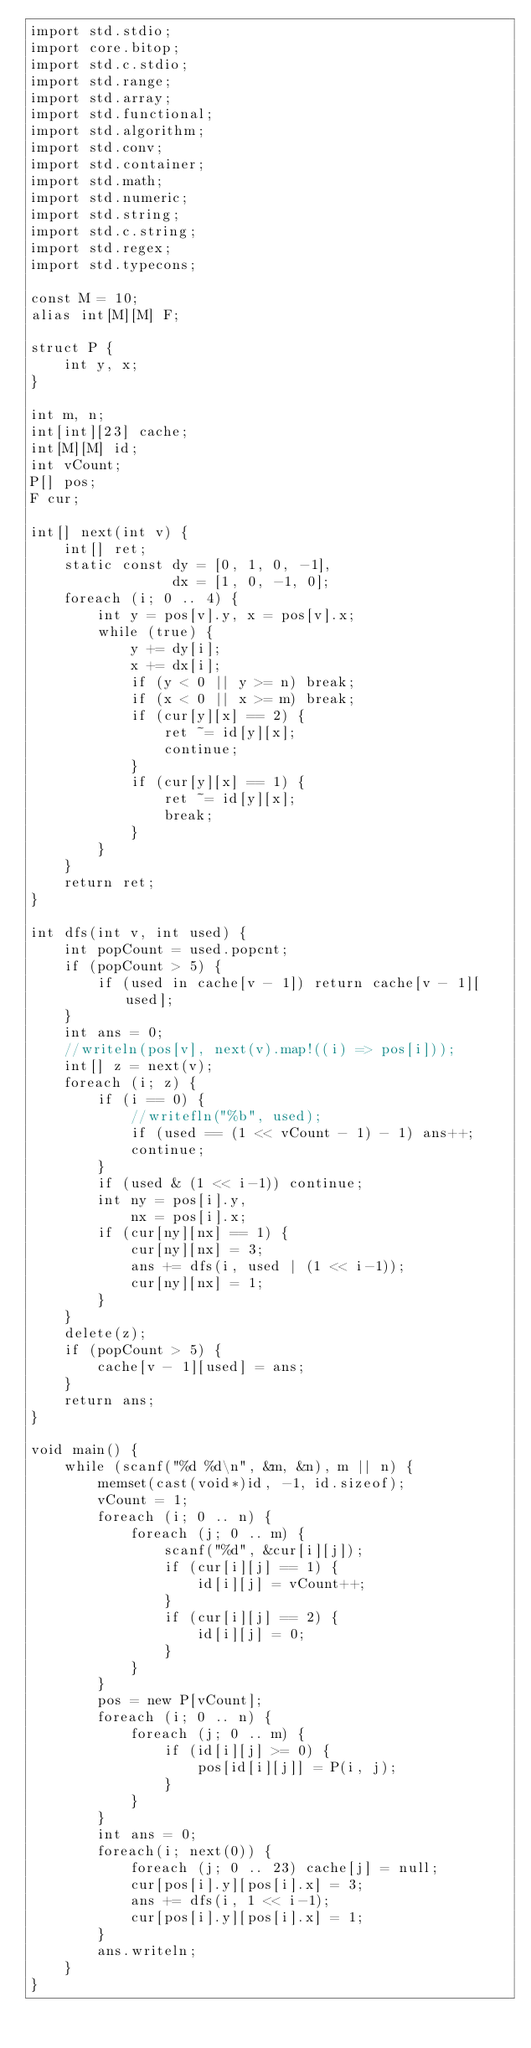Convert code to text. <code><loc_0><loc_0><loc_500><loc_500><_D_>import std.stdio;
import core.bitop;
import std.c.stdio;
import std.range;
import std.array;
import std.functional;
import std.algorithm;
import std.conv;
import std.container;
import std.math;
import std.numeric;
import std.string;
import std.c.string;
import std.regex;
import std.typecons;

const M = 10;
alias int[M][M] F;

struct P {
    int y, x;
}

int m, n;
int[int][23] cache;
int[M][M] id;
int vCount;
P[] pos;
F cur;

int[] next(int v) {
    int[] ret;
    static const dy = [0, 1, 0, -1],
                 dx = [1, 0, -1, 0];
    foreach (i; 0 .. 4) {
        int y = pos[v].y, x = pos[v].x;
        while (true) {
            y += dy[i];
            x += dx[i];
            if (y < 0 || y >= n) break;
            if (x < 0 || x >= m) break;
            if (cur[y][x] == 2) {
                ret ~= id[y][x];
                continue;
            }
            if (cur[y][x] == 1) {
                ret ~= id[y][x];
                break;
            }
        }
    }
    return ret;
}

int dfs(int v, int used) {
    int popCount = used.popcnt;
    if (popCount > 5) {
        if (used in cache[v - 1]) return cache[v - 1][used];
    }
    int ans = 0;
    //writeln(pos[v], next(v).map!((i) => pos[i]));
    int[] z = next(v);
    foreach (i; z) {
        if (i == 0) {
            //writefln("%b", used);
            if (used == (1 << vCount - 1) - 1) ans++;
            continue;
        }
        if (used & (1 << i-1)) continue;
        int ny = pos[i].y,
            nx = pos[i].x;
        if (cur[ny][nx] == 1) {
            cur[ny][nx] = 3;
            ans += dfs(i, used | (1 << i-1));
            cur[ny][nx] = 1;
        } 
    }
    delete(z);
    if (popCount > 5) {
        cache[v - 1][used] = ans;
    }
    return ans;
}

void main() {
    while (scanf("%d %d\n", &m, &n), m || n) {
        memset(cast(void*)id, -1, id.sizeof);
        vCount = 1;
        foreach (i; 0 .. n) {
            foreach (j; 0 .. m) {
                scanf("%d", &cur[i][j]);
                if (cur[i][j] == 1) {
                    id[i][j] = vCount++;
                }
                if (cur[i][j] == 2) {
                    id[i][j] = 0;
                }
            }
        }
        pos = new P[vCount];
        foreach (i; 0 .. n) {
            foreach (j; 0 .. m) {
                if (id[i][j] >= 0) {
                    pos[id[i][j]] = P(i, j);
                }
            }
        }
        int ans = 0;
        foreach(i; next(0)) {
            foreach (j; 0 .. 23) cache[j] = null;
            cur[pos[i].y][pos[i].x] = 3;
            ans += dfs(i, 1 << i-1);
            cur[pos[i].y][pos[i].x] = 1;
        }
        ans.writeln;
    }
}</code> 